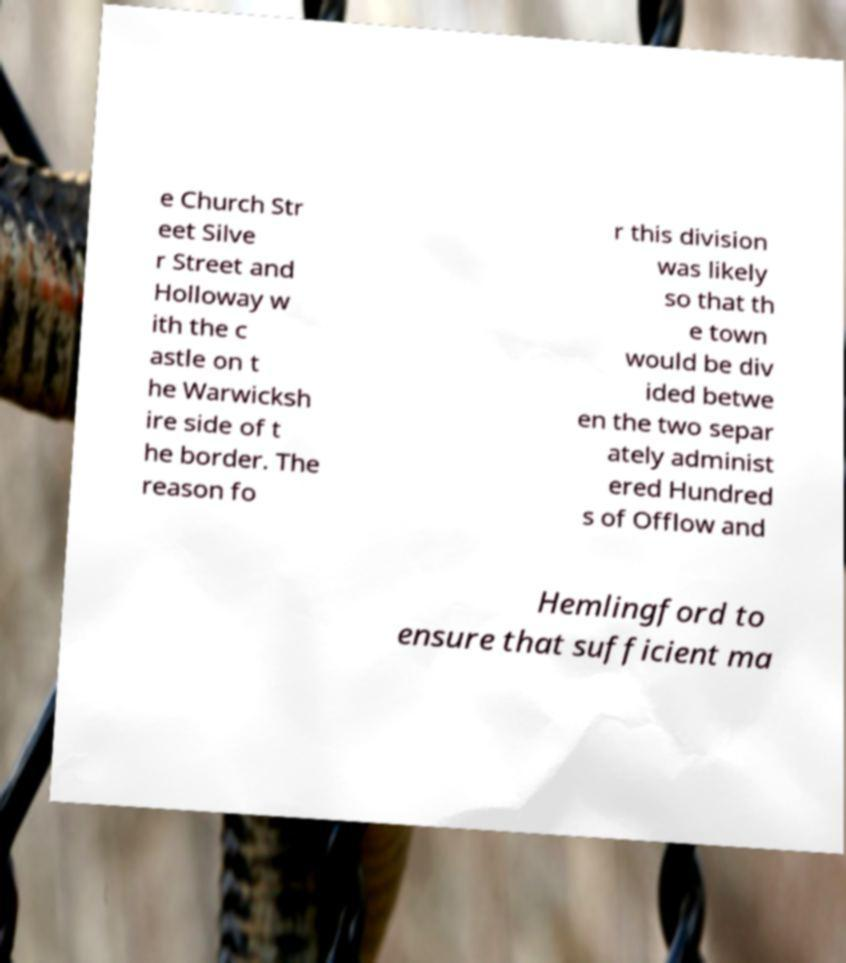For documentation purposes, I need the text within this image transcribed. Could you provide that? e Church Str eet Silve r Street and Holloway w ith the c astle on t he Warwicksh ire side of t he border. The reason fo r this division was likely so that th e town would be div ided betwe en the two separ ately administ ered Hundred s of Offlow and Hemlingford to ensure that sufficient ma 